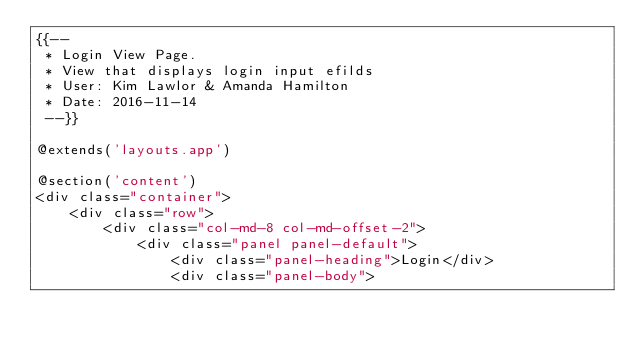<code> <loc_0><loc_0><loc_500><loc_500><_PHP_>{{--
 * Login View Page.
 * View that displays login input efilds
 * User: Kim Lawlor & Amanda Hamilton
 * Date: 2016-11-14
 --}}

@extends('layouts.app')

@section('content')
<div class="container">
    <div class="row">
        <div class="col-md-8 col-md-offset-2">
            <div class="panel panel-default">
                <div class="panel-heading">Login</div>
                <div class="panel-body"></code> 